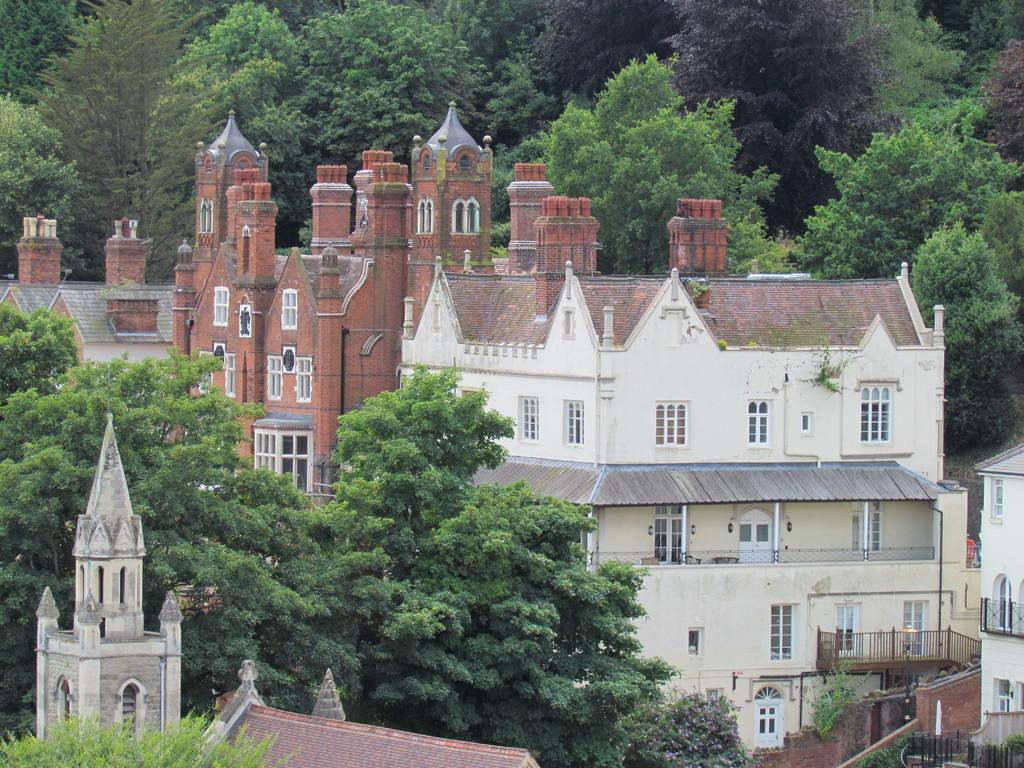What type of natural elements can be seen in the image? There are many trees in the image. What type of man-made structures can be seen in the image? There are many buildings in the image. Can you describe the landscape in the image? The landscape features a combination of natural elements (trees) and man-made structures (buildings). What type of bead is hanging from the tree in the image? There is no bead present in the image; it features trees and buildings. Can you describe the stranger walking through the yard in the image? There is no stranger or yard present in the image; it only features trees and buildings. 